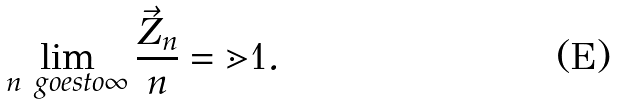<formula> <loc_0><loc_0><loc_500><loc_500>\lim _ { n \ g o e s t o \infty } \frac { \vec { Z } _ { n } } { n } = \mathbb { m } { 1 } .</formula> 